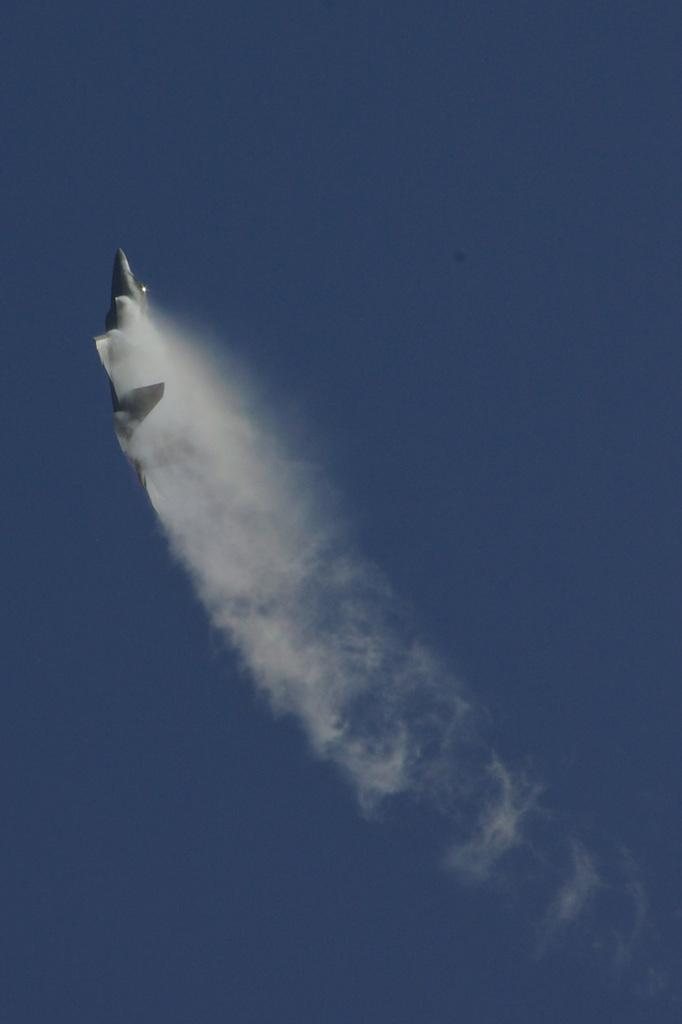What is the main subject of the image? The main subject of the image is an aeroplane. What is the aeroplane doing in the image? The aeroplane is flying in the sky. What type of attraction can be seen in the image? There is no attraction present in the image; it features an aeroplane flying in the sky. What type of cast is visible in the image? There is no cast present in the image; it features an aeroplane flying in the sky. 